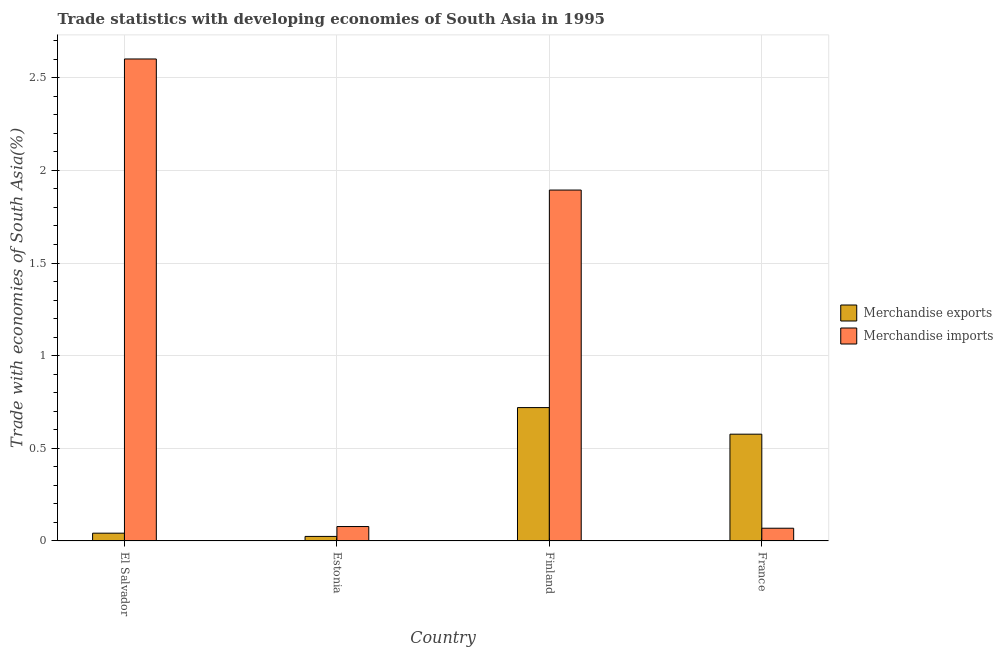How many different coloured bars are there?
Offer a terse response. 2. Are the number of bars per tick equal to the number of legend labels?
Provide a succinct answer. Yes. What is the label of the 1st group of bars from the left?
Provide a succinct answer. El Salvador. In how many cases, is the number of bars for a given country not equal to the number of legend labels?
Your response must be concise. 0. What is the merchandise imports in El Salvador?
Offer a very short reply. 2.6. Across all countries, what is the maximum merchandise exports?
Your answer should be compact. 0.72. Across all countries, what is the minimum merchandise exports?
Keep it short and to the point. 0.02. In which country was the merchandise imports maximum?
Offer a very short reply. El Salvador. In which country was the merchandise exports minimum?
Make the answer very short. Estonia. What is the total merchandise exports in the graph?
Provide a succinct answer. 1.36. What is the difference between the merchandise exports in El Salvador and that in Estonia?
Provide a succinct answer. 0.02. What is the difference between the merchandise imports in France and the merchandise exports in Finland?
Your response must be concise. -0.65. What is the average merchandise imports per country?
Keep it short and to the point. 1.16. What is the difference between the merchandise exports and merchandise imports in France?
Your answer should be very brief. 0.51. In how many countries, is the merchandise exports greater than 0.7 %?
Provide a short and direct response. 1. What is the ratio of the merchandise exports in El Salvador to that in France?
Make the answer very short. 0.07. Is the merchandise imports in Finland less than that in France?
Offer a terse response. No. Is the difference between the merchandise exports in El Salvador and France greater than the difference between the merchandise imports in El Salvador and France?
Ensure brevity in your answer.  No. What is the difference between the highest and the second highest merchandise exports?
Make the answer very short. 0.14. What is the difference between the highest and the lowest merchandise imports?
Provide a short and direct response. 2.53. What does the 2nd bar from the left in France represents?
Provide a succinct answer. Merchandise imports. How many bars are there?
Provide a short and direct response. 8. Are all the bars in the graph horizontal?
Your response must be concise. No. How many countries are there in the graph?
Your response must be concise. 4. What is the difference between two consecutive major ticks on the Y-axis?
Your response must be concise. 0.5. Does the graph contain any zero values?
Offer a terse response. No. How many legend labels are there?
Provide a short and direct response. 2. What is the title of the graph?
Your answer should be compact. Trade statistics with developing economies of South Asia in 1995. Does "% of gross capital formation" appear as one of the legend labels in the graph?
Your response must be concise. No. What is the label or title of the X-axis?
Provide a succinct answer. Country. What is the label or title of the Y-axis?
Offer a very short reply. Trade with economies of South Asia(%). What is the Trade with economies of South Asia(%) of Merchandise exports in El Salvador?
Give a very brief answer. 0.04. What is the Trade with economies of South Asia(%) of Merchandise imports in El Salvador?
Ensure brevity in your answer.  2.6. What is the Trade with economies of South Asia(%) of Merchandise exports in Estonia?
Provide a succinct answer. 0.02. What is the Trade with economies of South Asia(%) of Merchandise imports in Estonia?
Your response must be concise. 0.08. What is the Trade with economies of South Asia(%) of Merchandise exports in Finland?
Your answer should be compact. 0.72. What is the Trade with economies of South Asia(%) of Merchandise imports in Finland?
Provide a succinct answer. 1.89. What is the Trade with economies of South Asia(%) of Merchandise exports in France?
Offer a terse response. 0.58. What is the Trade with economies of South Asia(%) in Merchandise imports in France?
Your response must be concise. 0.07. Across all countries, what is the maximum Trade with economies of South Asia(%) of Merchandise exports?
Your answer should be compact. 0.72. Across all countries, what is the maximum Trade with economies of South Asia(%) of Merchandise imports?
Offer a very short reply. 2.6. Across all countries, what is the minimum Trade with economies of South Asia(%) of Merchandise exports?
Keep it short and to the point. 0.02. Across all countries, what is the minimum Trade with economies of South Asia(%) of Merchandise imports?
Offer a terse response. 0.07. What is the total Trade with economies of South Asia(%) in Merchandise exports in the graph?
Provide a succinct answer. 1.36. What is the total Trade with economies of South Asia(%) in Merchandise imports in the graph?
Give a very brief answer. 4.64. What is the difference between the Trade with economies of South Asia(%) in Merchandise exports in El Salvador and that in Estonia?
Ensure brevity in your answer.  0.02. What is the difference between the Trade with economies of South Asia(%) in Merchandise imports in El Salvador and that in Estonia?
Your answer should be compact. 2.52. What is the difference between the Trade with economies of South Asia(%) in Merchandise exports in El Salvador and that in Finland?
Your response must be concise. -0.68. What is the difference between the Trade with economies of South Asia(%) of Merchandise imports in El Salvador and that in Finland?
Your answer should be compact. 0.71. What is the difference between the Trade with economies of South Asia(%) in Merchandise exports in El Salvador and that in France?
Provide a succinct answer. -0.53. What is the difference between the Trade with economies of South Asia(%) in Merchandise imports in El Salvador and that in France?
Your answer should be compact. 2.53. What is the difference between the Trade with economies of South Asia(%) of Merchandise exports in Estonia and that in Finland?
Provide a short and direct response. -0.7. What is the difference between the Trade with economies of South Asia(%) in Merchandise imports in Estonia and that in Finland?
Your answer should be very brief. -1.82. What is the difference between the Trade with economies of South Asia(%) in Merchandise exports in Estonia and that in France?
Give a very brief answer. -0.55. What is the difference between the Trade with economies of South Asia(%) in Merchandise imports in Estonia and that in France?
Make the answer very short. 0.01. What is the difference between the Trade with economies of South Asia(%) in Merchandise exports in Finland and that in France?
Offer a very short reply. 0.14. What is the difference between the Trade with economies of South Asia(%) in Merchandise imports in Finland and that in France?
Make the answer very short. 1.83. What is the difference between the Trade with economies of South Asia(%) of Merchandise exports in El Salvador and the Trade with economies of South Asia(%) of Merchandise imports in Estonia?
Offer a very short reply. -0.04. What is the difference between the Trade with economies of South Asia(%) in Merchandise exports in El Salvador and the Trade with economies of South Asia(%) in Merchandise imports in Finland?
Offer a terse response. -1.85. What is the difference between the Trade with economies of South Asia(%) of Merchandise exports in El Salvador and the Trade with economies of South Asia(%) of Merchandise imports in France?
Your answer should be compact. -0.03. What is the difference between the Trade with economies of South Asia(%) in Merchandise exports in Estonia and the Trade with economies of South Asia(%) in Merchandise imports in Finland?
Provide a short and direct response. -1.87. What is the difference between the Trade with economies of South Asia(%) of Merchandise exports in Estonia and the Trade with economies of South Asia(%) of Merchandise imports in France?
Your response must be concise. -0.04. What is the difference between the Trade with economies of South Asia(%) in Merchandise exports in Finland and the Trade with economies of South Asia(%) in Merchandise imports in France?
Offer a terse response. 0.65. What is the average Trade with economies of South Asia(%) in Merchandise exports per country?
Offer a terse response. 0.34. What is the average Trade with economies of South Asia(%) in Merchandise imports per country?
Your response must be concise. 1.16. What is the difference between the Trade with economies of South Asia(%) of Merchandise exports and Trade with economies of South Asia(%) of Merchandise imports in El Salvador?
Make the answer very short. -2.56. What is the difference between the Trade with economies of South Asia(%) of Merchandise exports and Trade with economies of South Asia(%) of Merchandise imports in Estonia?
Your answer should be very brief. -0.05. What is the difference between the Trade with economies of South Asia(%) of Merchandise exports and Trade with economies of South Asia(%) of Merchandise imports in Finland?
Offer a terse response. -1.17. What is the difference between the Trade with economies of South Asia(%) of Merchandise exports and Trade with economies of South Asia(%) of Merchandise imports in France?
Ensure brevity in your answer.  0.51. What is the ratio of the Trade with economies of South Asia(%) of Merchandise exports in El Salvador to that in Estonia?
Give a very brief answer. 1.71. What is the ratio of the Trade with economies of South Asia(%) of Merchandise imports in El Salvador to that in Estonia?
Provide a short and direct response. 33.37. What is the ratio of the Trade with economies of South Asia(%) in Merchandise exports in El Salvador to that in Finland?
Your response must be concise. 0.06. What is the ratio of the Trade with economies of South Asia(%) in Merchandise imports in El Salvador to that in Finland?
Offer a very short reply. 1.37. What is the ratio of the Trade with economies of South Asia(%) in Merchandise exports in El Salvador to that in France?
Make the answer very short. 0.07. What is the ratio of the Trade with economies of South Asia(%) in Merchandise imports in El Salvador to that in France?
Ensure brevity in your answer.  37.78. What is the ratio of the Trade with economies of South Asia(%) of Merchandise exports in Estonia to that in Finland?
Give a very brief answer. 0.03. What is the ratio of the Trade with economies of South Asia(%) of Merchandise imports in Estonia to that in Finland?
Ensure brevity in your answer.  0.04. What is the ratio of the Trade with economies of South Asia(%) in Merchandise exports in Estonia to that in France?
Your answer should be compact. 0.04. What is the ratio of the Trade with economies of South Asia(%) in Merchandise imports in Estonia to that in France?
Keep it short and to the point. 1.13. What is the ratio of the Trade with economies of South Asia(%) of Merchandise exports in Finland to that in France?
Ensure brevity in your answer.  1.25. What is the ratio of the Trade with economies of South Asia(%) in Merchandise imports in Finland to that in France?
Your answer should be very brief. 27.51. What is the difference between the highest and the second highest Trade with economies of South Asia(%) in Merchandise exports?
Keep it short and to the point. 0.14. What is the difference between the highest and the second highest Trade with economies of South Asia(%) of Merchandise imports?
Your response must be concise. 0.71. What is the difference between the highest and the lowest Trade with economies of South Asia(%) in Merchandise exports?
Give a very brief answer. 0.7. What is the difference between the highest and the lowest Trade with economies of South Asia(%) in Merchandise imports?
Ensure brevity in your answer.  2.53. 